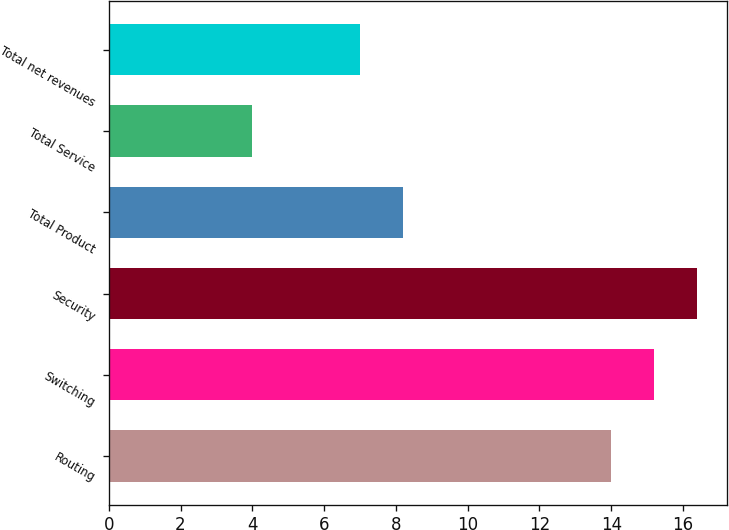<chart> <loc_0><loc_0><loc_500><loc_500><bar_chart><fcel>Routing<fcel>Switching<fcel>Security<fcel>Total Product<fcel>Total Service<fcel>Total net revenues<nl><fcel>14<fcel>15.2<fcel>16.4<fcel>8.2<fcel>4<fcel>7<nl></chart> 